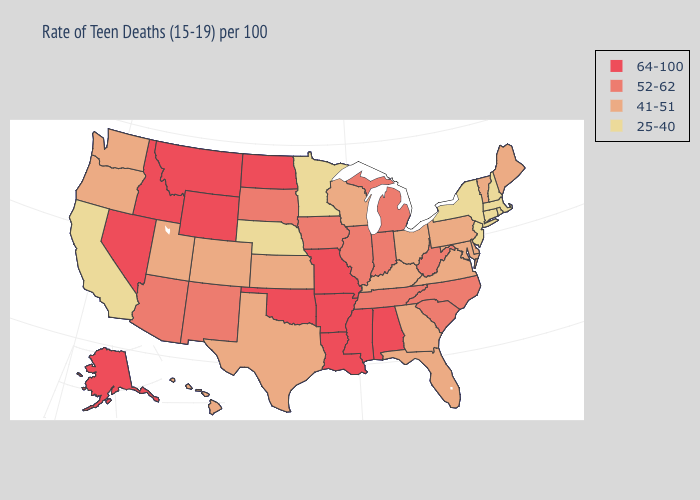Among the states that border Wisconsin , does Minnesota have the highest value?
Keep it brief. No. Does Kansas have a lower value than Tennessee?
Be succinct. Yes. Does Minnesota have the highest value in the MidWest?
Give a very brief answer. No. Name the states that have a value in the range 52-62?
Short answer required. Arizona, Illinois, Indiana, Iowa, Michigan, New Mexico, North Carolina, South Carolina, South Dakota, Tennessee, West Virginia. Does the map have missing data?
Short answer required. No. Name the states that have a value in the range 52-62?
Give a very brief answer. Arizona, Illinois, Indiana, Iowa, Michigan, New Mexico, North Carolina, South Carolina, South Dakota, Tennessee, West Virginia. Name the states that have a value in the range 64-100?
Short answer required. Alabama, Alaska, Arkansas, Idaho, Louisiana, Mississippi, Missouri, Montana, Nevada, North Dakota, Oklahoma, Wyoming. What is the value of North Dakota?
Answer briefly. 64-100. Does Oregon have a lower value than Indiana?
Concise answer only. Yes. Does Wisconsin have a lower value than Michigan?
Answer briefly. Yes. Among the states that border Montana , which have the lowest value?
Write a very short answer. South Dakota. What is the value of Iowa?
Write a very short answer. 52-62. Name the states that have a value in the range 52-62?
Be succinct. Arizona, Illinois, Indiana, Iowa, Michigan, New Mexico, North Carolina, South Carolina, South Dakota, Tennessee, West Virginia. What is the value of Iowa?
Short answer required. 52-62. 